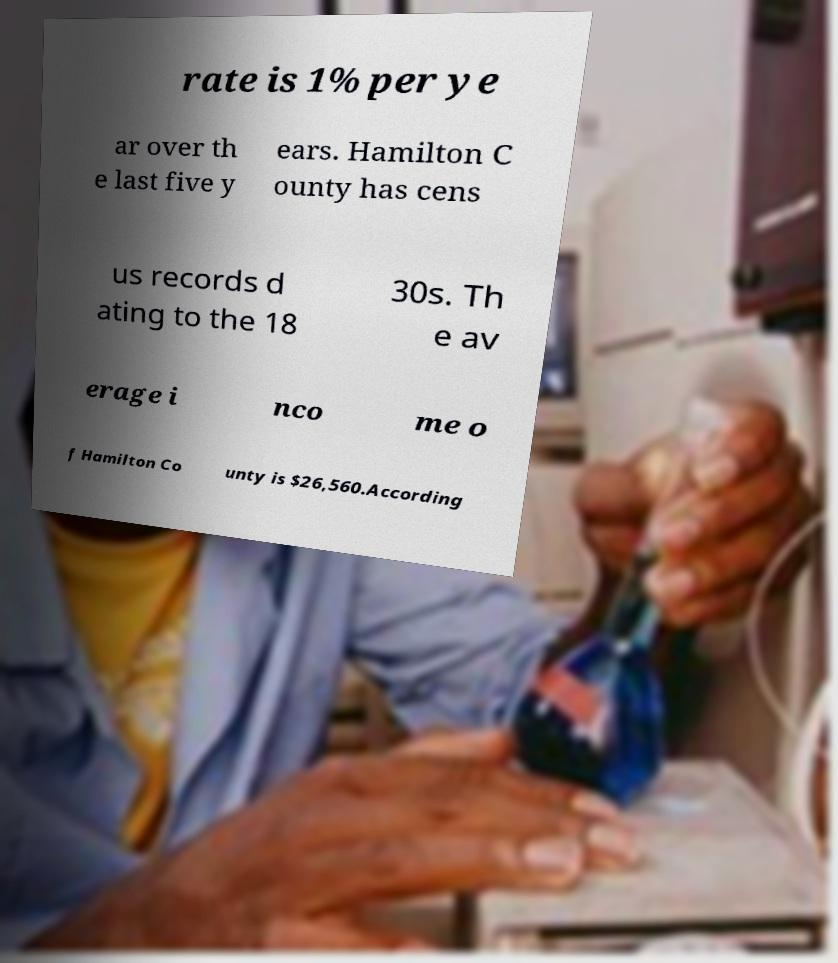Could you assist in decoding the text presented in this image and type it out clearly? rate is 1% per ye ar over th e last five y ears. Hamilton C ounty has cens us records d ating to the 18 30s. Th e av erage i nco me o f Hamilton Co unty is $26,560.According 